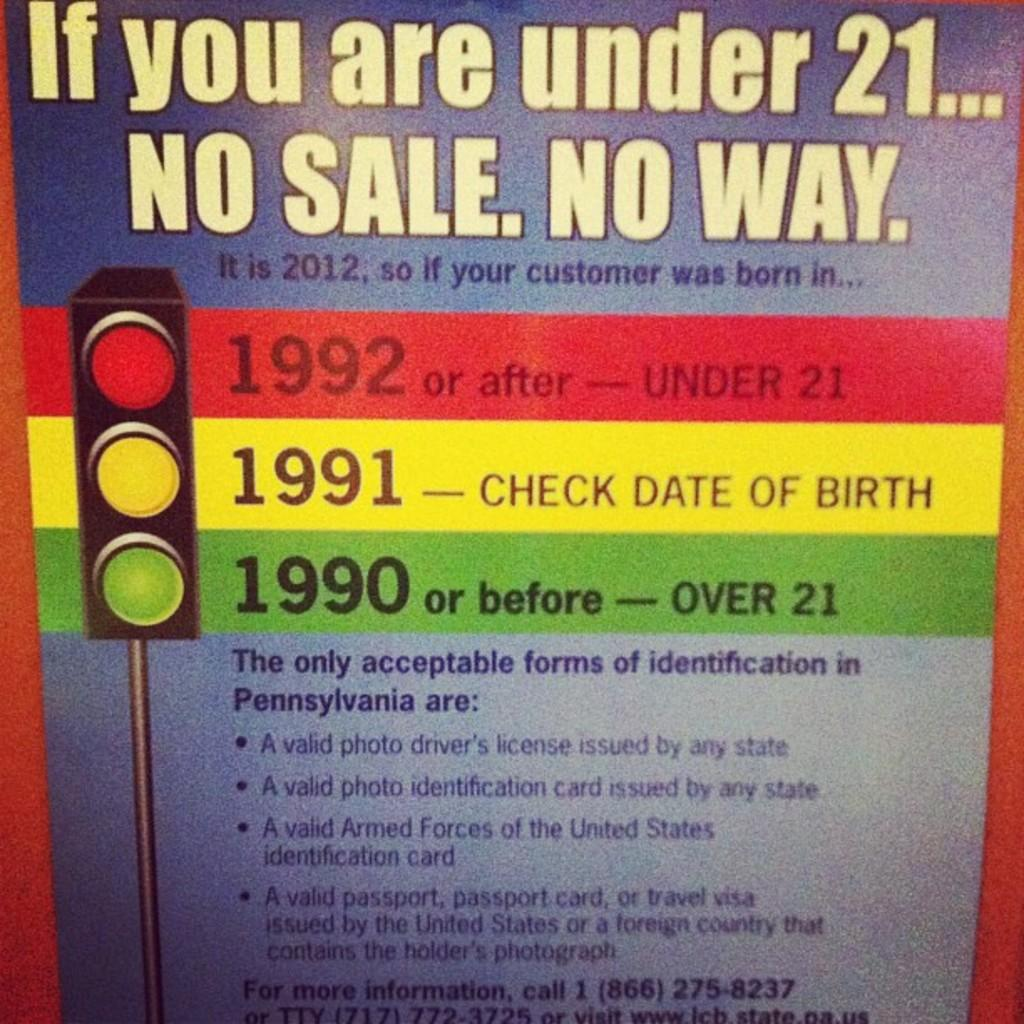<image>
Create a compact narrative representing the image presented. A sign advising laws of photo identification in Pennsylvania. 